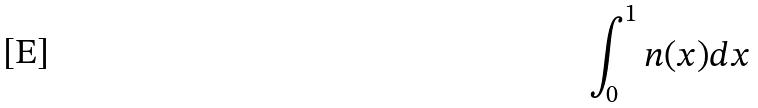<formula> <loc_0><loc_0><loc_500><loc_500>\int _ { 0 } ^ { 1 } n ( x ) d x</formula> 